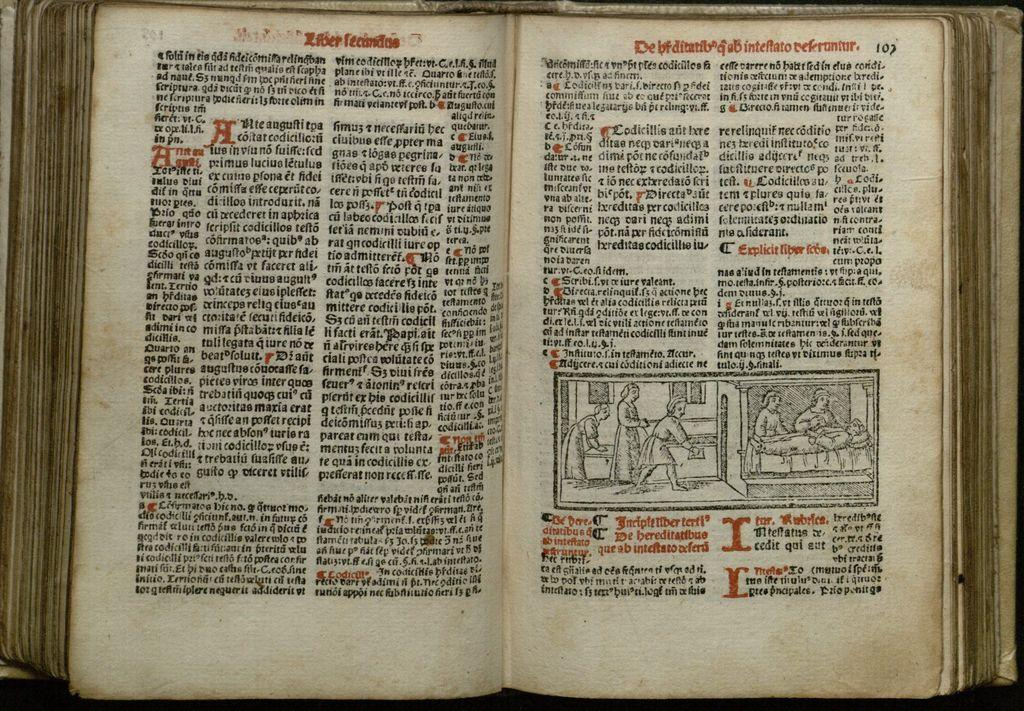<image>
Describe the image concisely. A book that is written in froreign language appears to be open to page 102. 